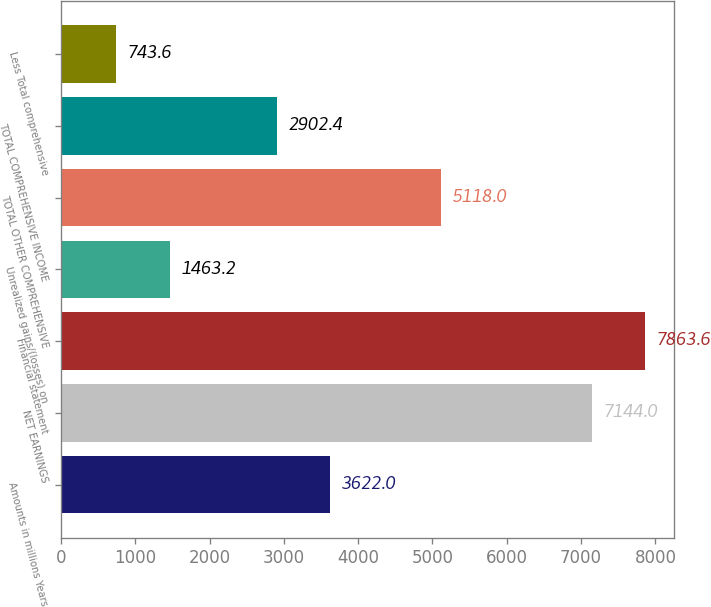<chart> <loc_0><loc_0><loc_500><loc_500><bar_chart><fcel>Amounts in millions Years<fcel>NET EARNINGS<fcel>Financial statement<fcel>Unrealized gains/(losses) on<fcel>TOTAL OTHER COMPREHENSIVE<fcel>TOTAL COMPREHENSIVE INCOME<fcel>Less Total comprehensive<nl><fcel>3622<fcel>7144<fcel>7863.6<fcel>1463.2<fcel>5118<fcel>2902.4<fcel>743.6<nl></chart> 